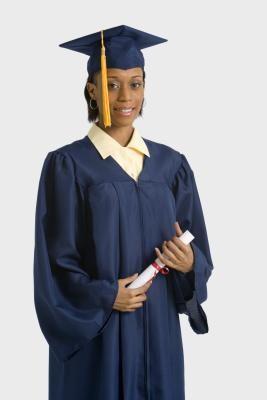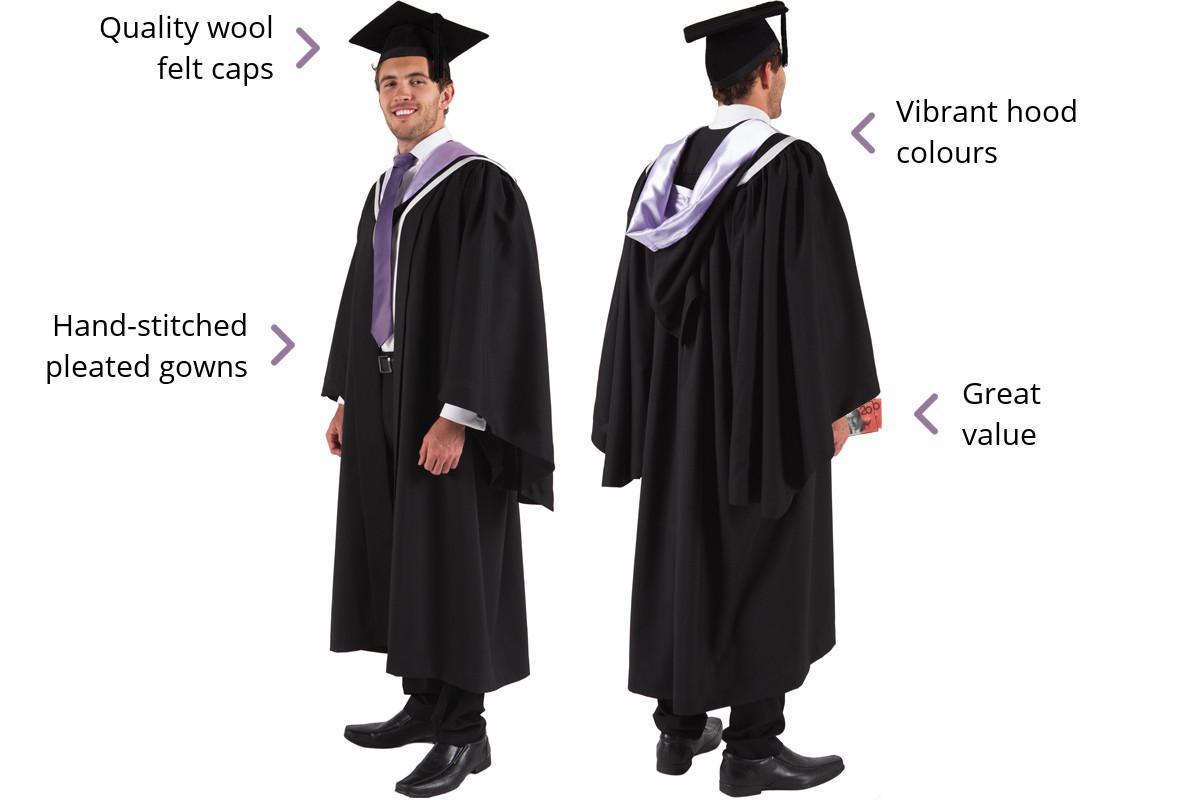The first image is the image on the left, the second image is the image on the right. Evaluate the accuracy of this statement regarding the images: "THere are exactly two people in the image on the left.". Is it true? Answer yes or no. No. 